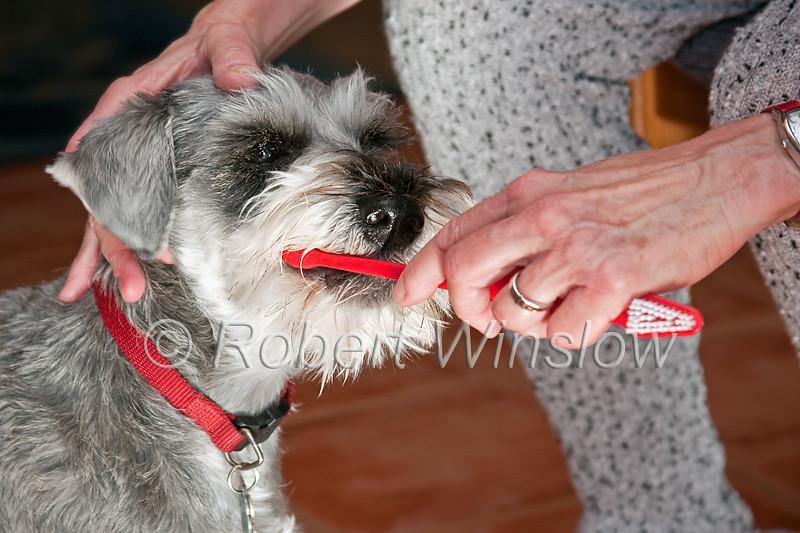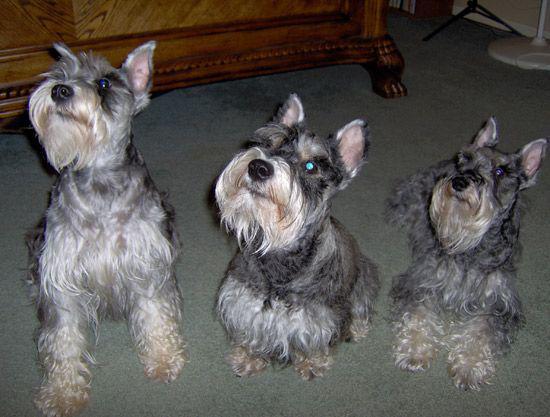The first image is the image on the left, the second image is the image on the right. Given the left and right images, does the statement "There are four dogs total." hold true? Answer yes or no. Yes. 